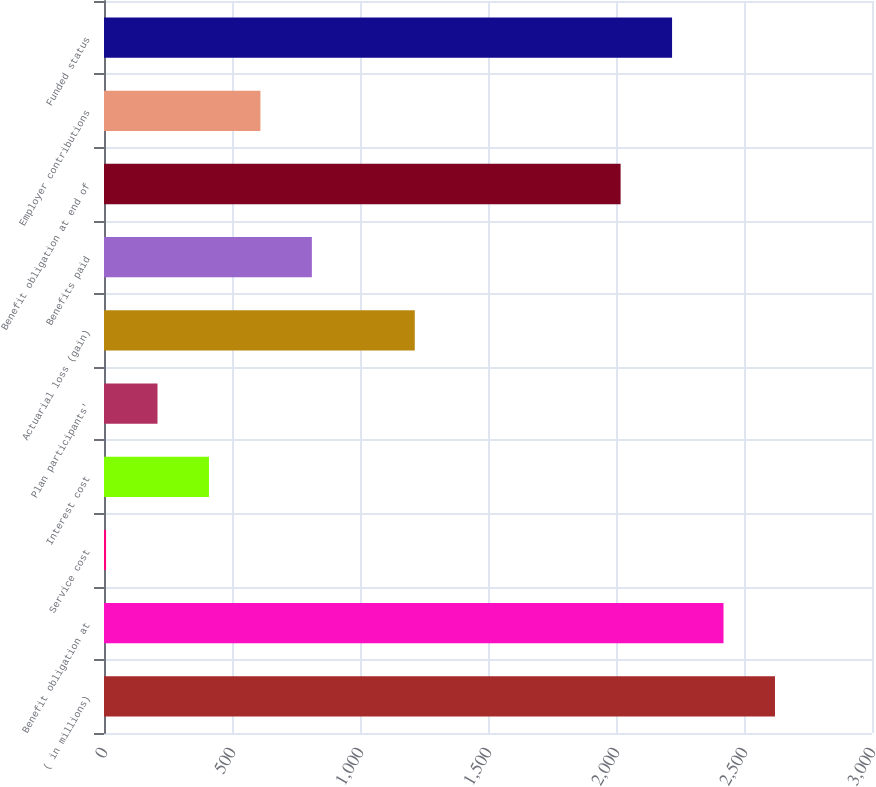<chart> <loc_0><loc_0><loc_500><loc_500><bar_chart><fcel>( in millions)<fcel>Benefit obligation at<fcel>Service cost<fcel>Interest cost<fcel>Plan participants'<fcel>Actuarial loss (gain)<fcel>Benefits paid<fcel>Benefit obligation at end of<fcel>Employer contributions<fcel>Funded status<nl><fcel>2621<fcel>2420<fcel>8<fcel>410<fcel>209<fcel>1214<fcel>812<fcel>2018<fcel>611<fcel>2219<nl></chart> 